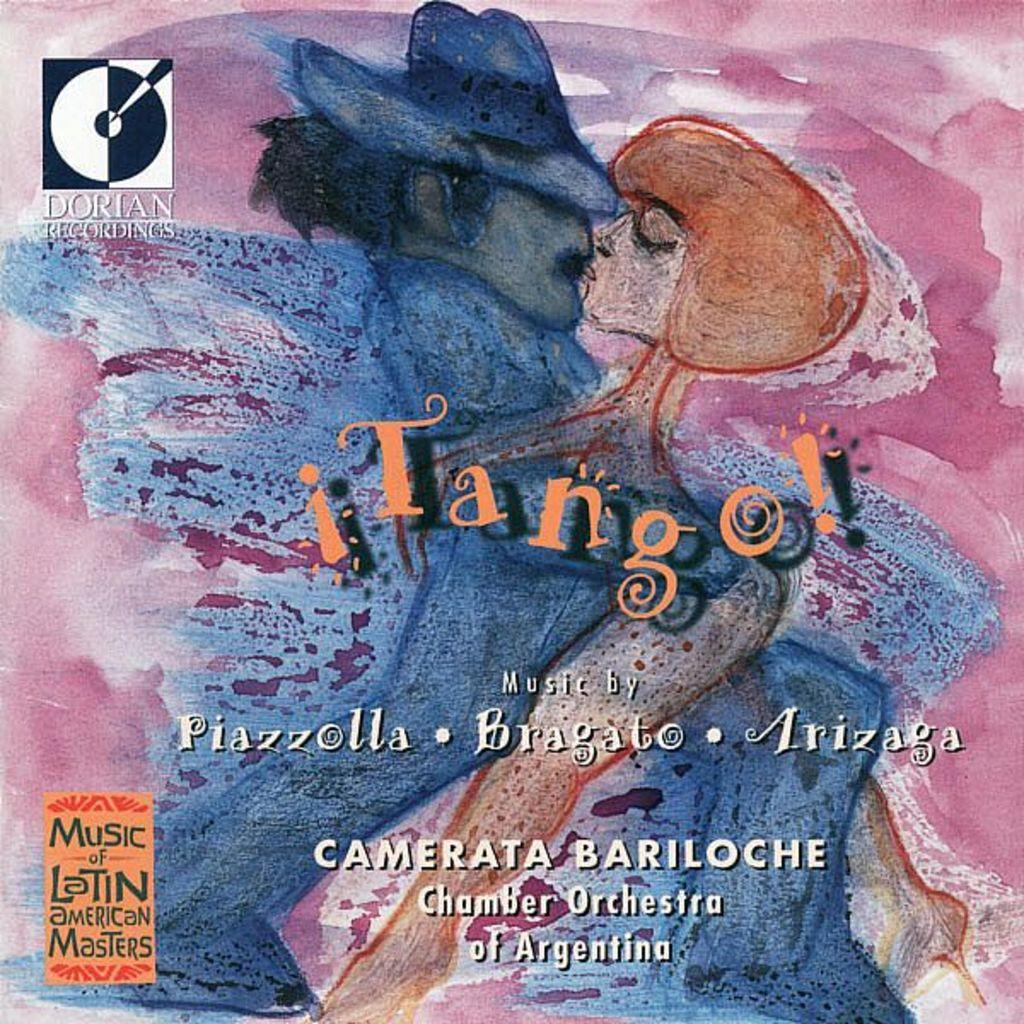<image>
Offer a succinct explanation of the picture presented. CD cover art that is pink and green with a man and a women and says Music of Latin American Masters. 